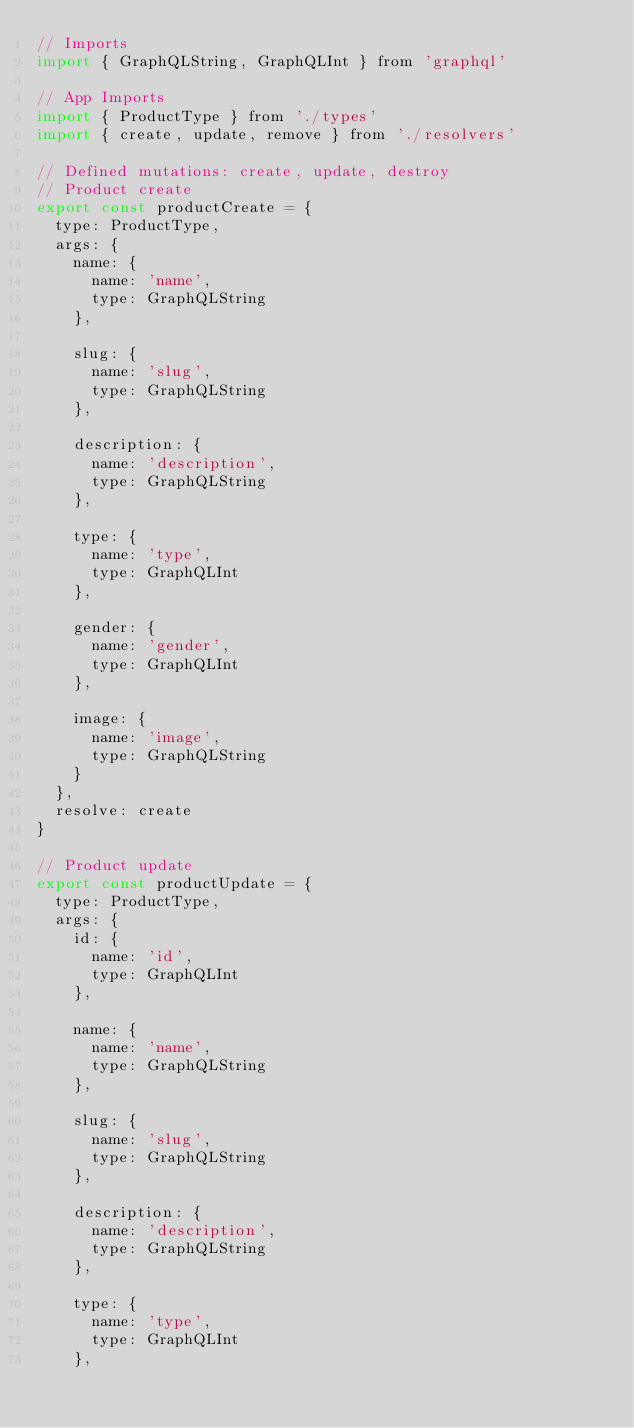<code> <loc_0><loc_0><loc_500><loc_500><_JavaScript_>// Imports
import { GraphQLString, GraphQLInt } from 'graphql'

// App Imports
import { ProductType } from './types'
import { create, update, remove } from './resolvers'

// Defined mutations: create, update, destroy
// Product create
export const productCreate = {
  type: ProductType,
  args: {
    name: {
      name: 'name',
      type: GraphQLString
    },

    slug: {
      name: 'slug',
      type: GraphQLString
    },

    description: {
      name: 'description',
      type: GraphQLString
    },

    type: {
      name: 'type',
      type: GraphQLInt
    },

    gender: {
      name: 'gender',
      type: GraphQLInt
    },

    image: {
      name: 'image',
      type: GraphQLString
    }
  },
  resolve: create
}

// Product update
export const productUpdate = {
  type: ProductType,
  args: {
    id: {
      name: 'id',
      type: GraphQLInt
    },

    name: {
      name: 'name',
      type: GraphQLString
    },

    slug: {
      name: 'slug',
      type: GraphQLString
    },

    description: {
      name: 'description',
      type: GraphQLString
    },

    type: {
      name: 'type',
      type: GraphQLInt
    },
</code> 